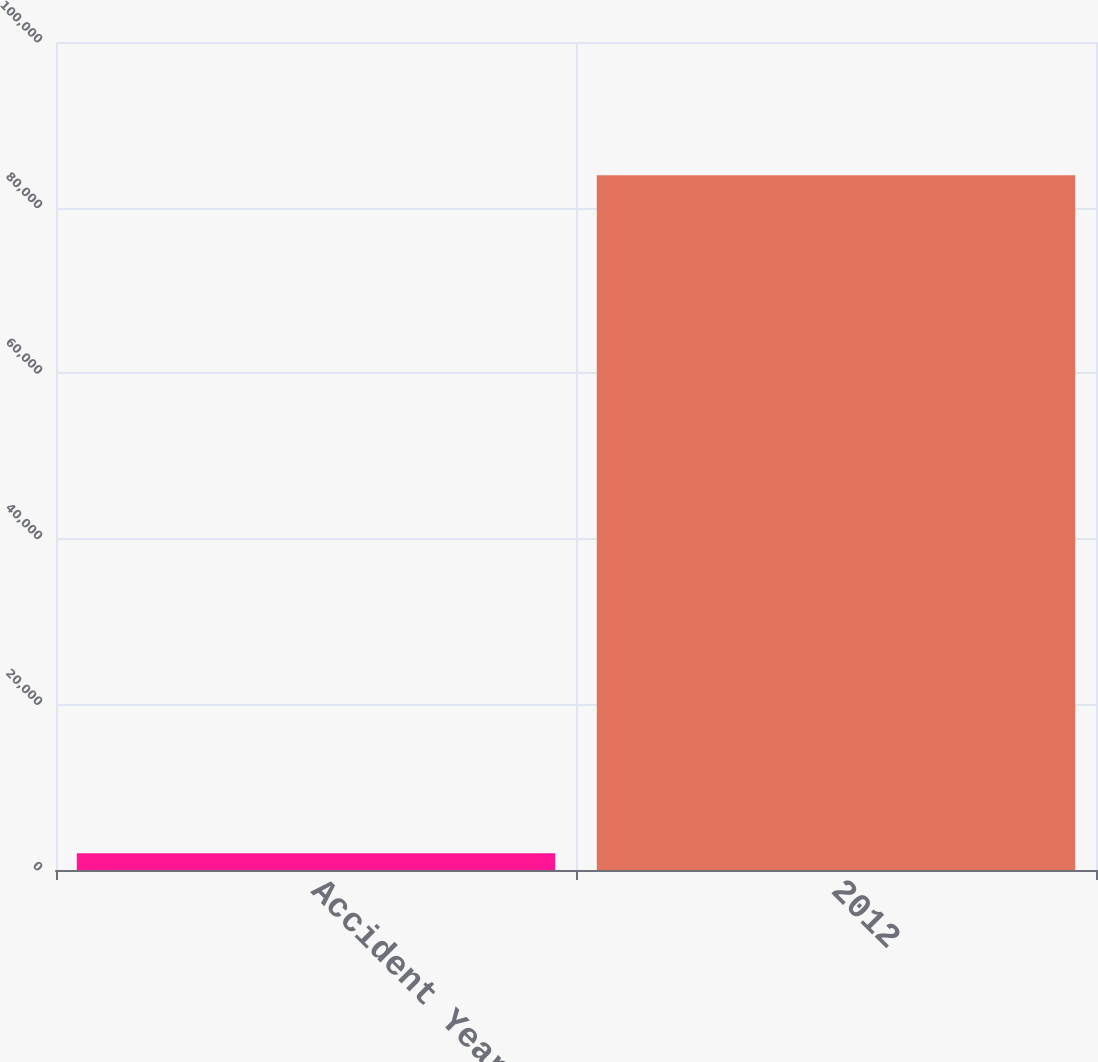Convert chart. <chart><loc_0><loc_0><loc_500><loc_500><bar_chart><fcel>Accident Year<fcel>2012<nl><fcel>2014<fcel>83919<nl></chart> 